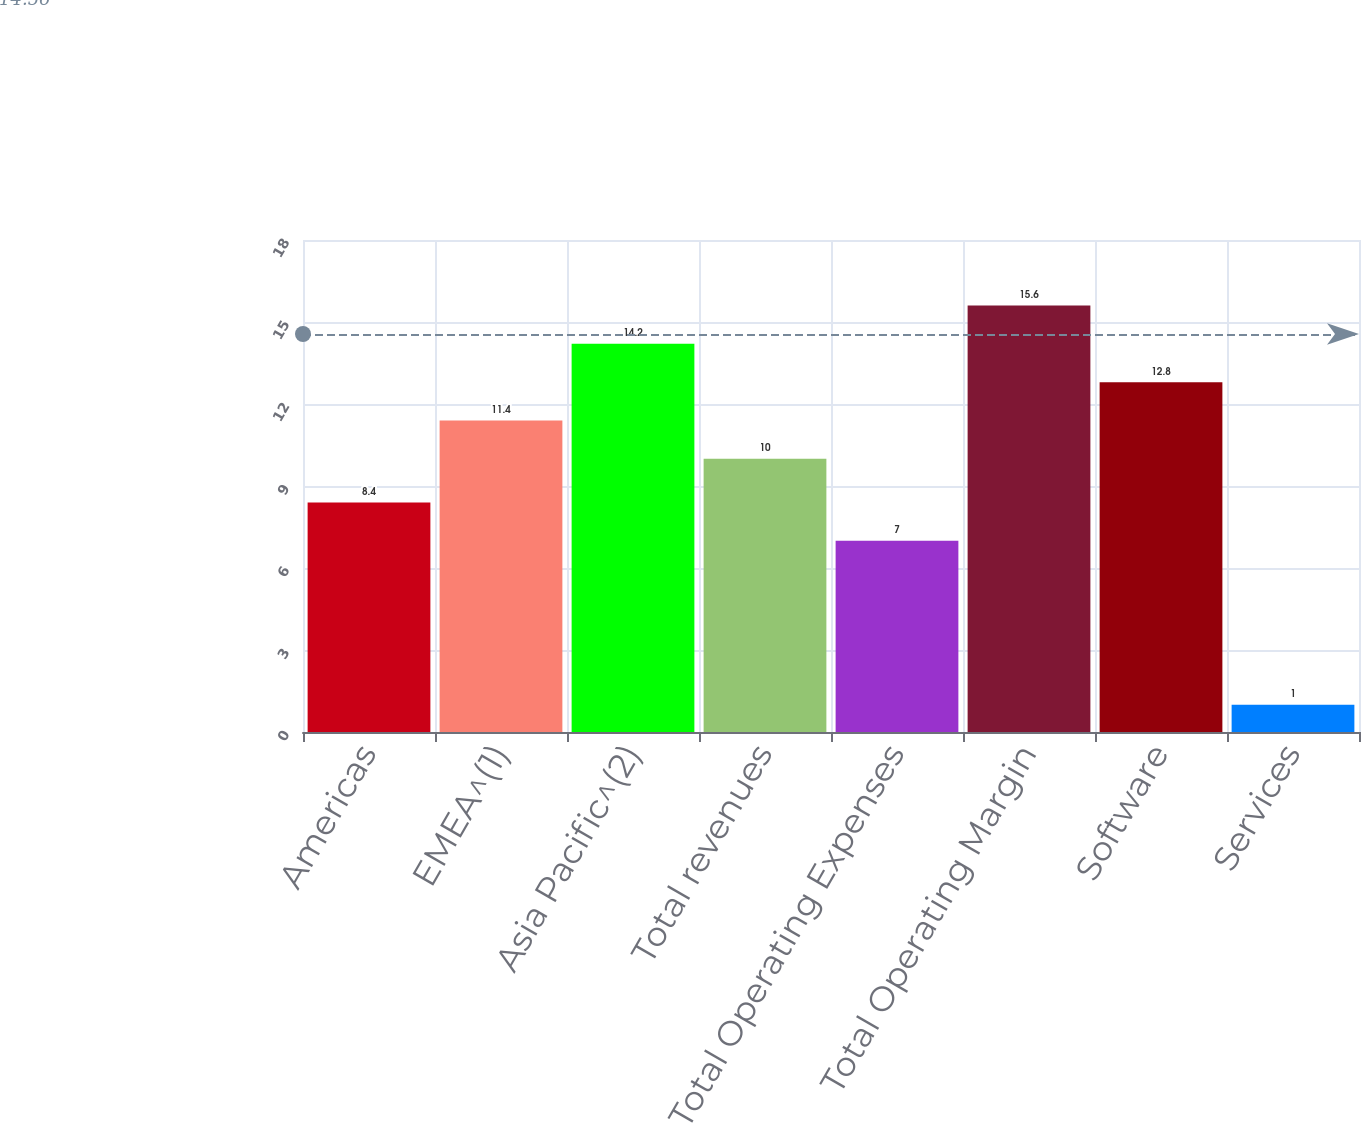<chart> <loc_0><loc_0><loc_500><loc_500><bar_chart><fcel>Americas<fcel>EMEA^(1)<fcel>Asia Pacific^(2)<fcel>Total revenues<fcel>Total Operating Expenses<fcel>Total Operating Margin<fcel>Software<fcel>Services<nl><fcel>8.4<fcel>11.4<fcel>14.2<fcel>10<fcel>7<fcel>15.6<fcel>12.8<fcel>1<nl></chart> 